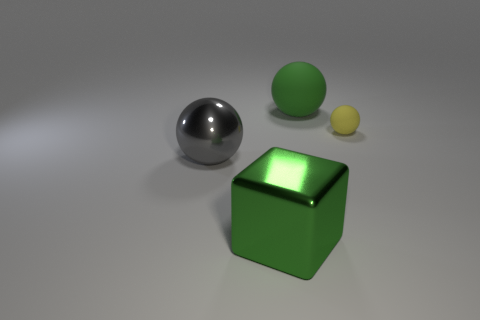The gray thing that is the same material as the big block is what size?
Offer a very short reply. Large. What is the material of the yellow sphere?
Make the answer very short. Rubber. What number of purple matte blocks are the same size as the green rubber ball?
Give a very brief answer. 0. The object that is the same color as the large metal cube is what shape?
Ensure brevity in your answer.  Sphere. Are there any red metal things that have the same shape as the yellow matte object?
Your answer should be very brief. No. What is the color of the metallic object that is the same size as the block?
Make the answer very short. Gray. There is a matte thing that is in front of the rubber sphere behind the tiny matte object; what color is it?
Your answer should be very brief. Yellow. There is a matte sphere that is to the left of the small matte thing; is it the same color as the large metallic cube?
Provide a short and direct response. Yes. The rubber thing behind the thing to the right of the big ball right of the large green cube is what shape?
Your response must be concise. Sphere. There is a large green object that is to the left of the big green ball; how many tiny rubber things are in front of it?
Your answer should be very brief. 0. 